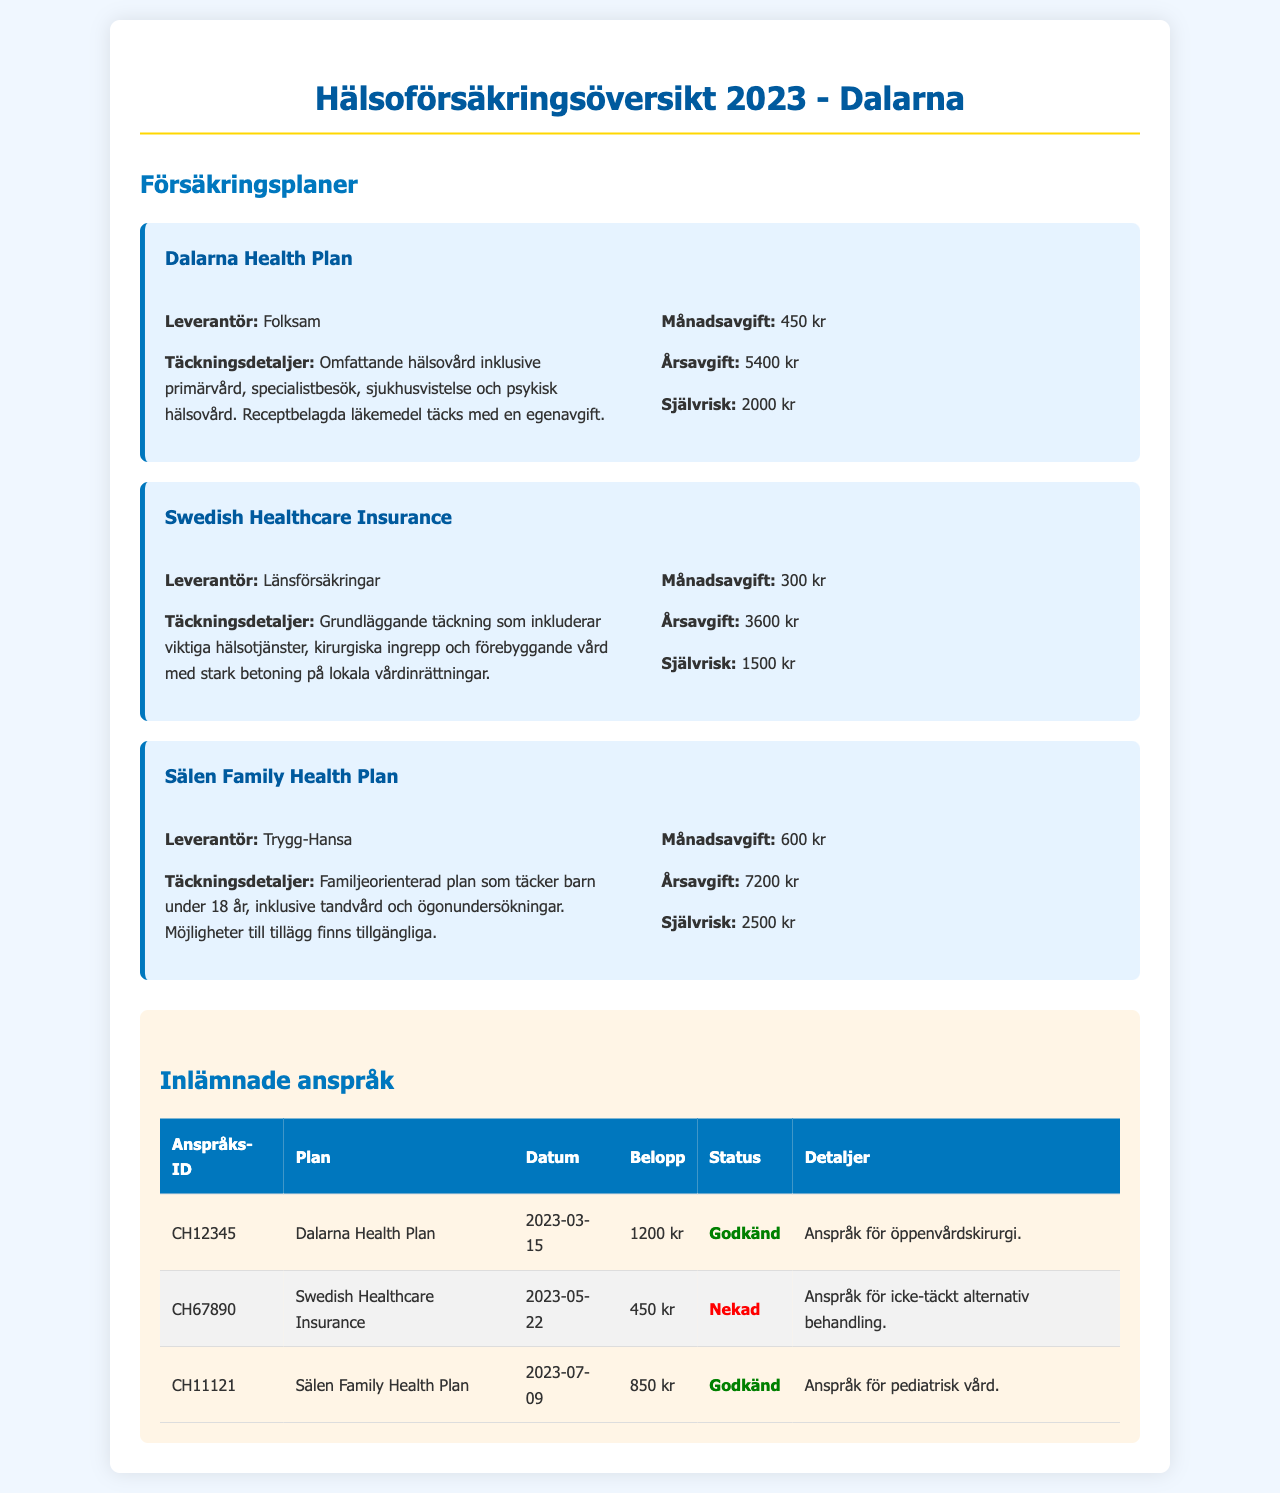what is the monthly fee for the Dalarna Health Plan? The monthly fee is specified in the document for the Dalarna Health Plan as 450 kr.
Answer: 450 kr what is the annual premium for the Sälen Family Health Plan? The annual premium is outlined for the Sälen Family Health Plan as 7200 kr.
Answer: 7200 kr how much is the deductible for the Swedish Healthcare Insurance? The deductible is mentioned in the document for the Swedish Healthcare Insurance as 1500 kr.
Answer: 1500 kr which provider offers the Sälen Family Health Plan? The document lists Trygg-Hansa as the provider for the Sälen Family Health Plan.
Answer: Trygg-Hansa what was the approved amount for the claim CH12345? The approved claim amount is detailed in the document for CH12345 as 1200 kr.
Answer: 1200 kr how many claims were approved in total? The summary in the document indicates a total of two claims were approved, one for CH12345 and one for CH11121.
Answer: 2 which plan has the lowest deductible? The document indicates that the Swedish Healthcare Insurance has the lowest deductible at 1500 kr.
Answer: Swedish Healthcare Insurance when was the denied claim filed for the Swedish Healthcare Insurance? The denied claim date is provided in the document as 2023-05-22.
Answer: 2023-05-22 what type of care does the Dalarna Health Plan cover? The document describes that it covers comprehensive health care, including primary care, specialist visits, hospital stays, and mental health care.
Answer: Comprehensive health care 